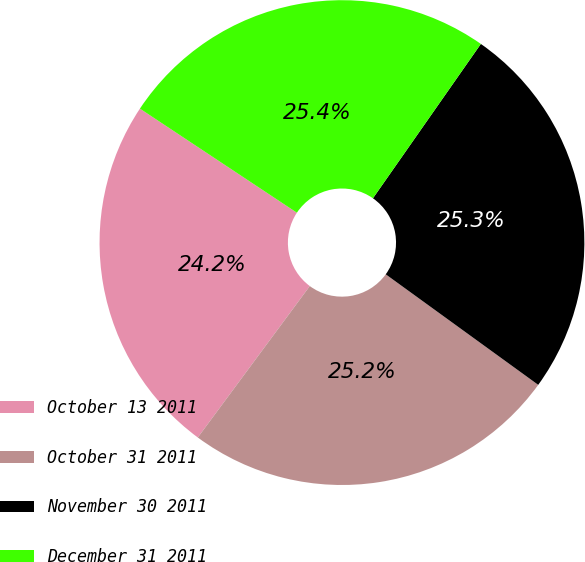Convert chart to OTSL. <chart><loc_0><loc_0><loc_500><loc_500><pie_chart><fcel>October 13 2011<fcel>October 31 2011<fcel>November 30 2011<fcel>December 31 2011<nl><fcel>24.18%<fcel>25.15%<fcel>25.27%<fcel>25.39%<nl></chart> 